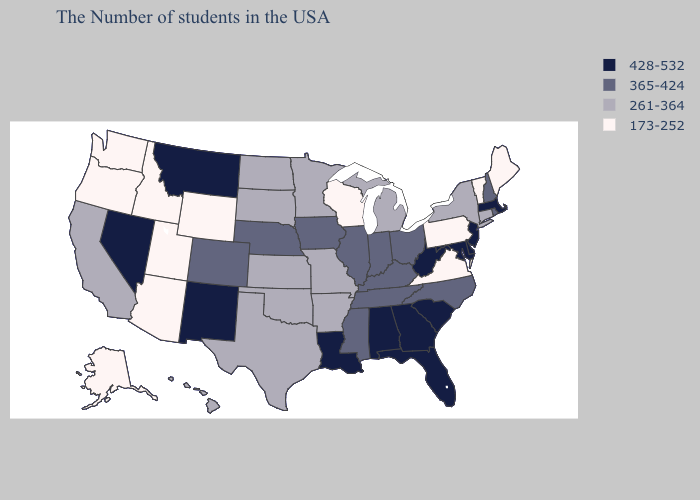Does the map have missing data?
Be succinct. No. Name the states that have a value in the range 428-532?
Answer briefly. Massachusetts, New Jersey, Delaware, Maryland, South Carolina, West Virginia, Florida, Georgia, Alabama, Louisiana, New Mexico, Montana, Nevada. Name the states that have a value in the range 173-252?
Keep it brief. Maine, Vermont, Pennsylvania, Virginia, Wisconsin, Wyoming, Utah, Arizona, Idaho, Washington, Oregon, Alaska. What is the value of Wisconsin?
Write a very short answer. 173-252. How many symbols are there in the legend?
Be succinct. 4. What is the lowest value in the USA?
Keep it brief. 173-252. Does the first symbol in the legend represent the smallest category?
Concise answer only. No. Name the states that have a value in the range 261-364?
Be succinct. Connecticut, New York, Michigan, Missouri, Arkansas, Minnesota, Kansas, Oklahoma, Texas, South Dakota, North Dakota, California, Hawaii. What is the value of Colorado?
Write a very short answer. 365-424. What is the value of Alaska?
Quick response, please. 173-252. Is the legend a continuous bar?
Answer briefly. No. Among the states that border Mississippi , does Louisiana have the lowest value?
Quick response, please. No. What is the lowest value in the Northeast?
Keep it brief. 173-252. What is the value of North Carolina?
Give a very brief answer. 365-424. Name the states that have a value in the range 428-532?
Write a very short answer. Massachusetts, New Jersey, Delaware, Maryland, South Carolina, West Virginia, Florida, Georgia, Alabama, Louisiana, New Mexico, Montana, Nevada. 